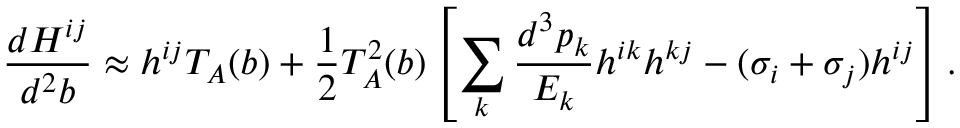Convert formula to latex. <formula><loc_0><loc_0><loc_500><loc_500>\frac { d H ^ { i j } } { d ^ { 2 } b } \approx h ^ { i j } T _ { A } ( b ) + \frac { 1 } { 2 } T _ { A } ^ { 2 } ( b ) \left [ \sum _ { k } \frac { d ^ { 3 } p _ { k } } { E _ { k } } h ^ { i k } h ^ { k j } - ( \sigma _ { i } + \sigma _ { j } ) h ^ { i j } \right ] .</formula> 